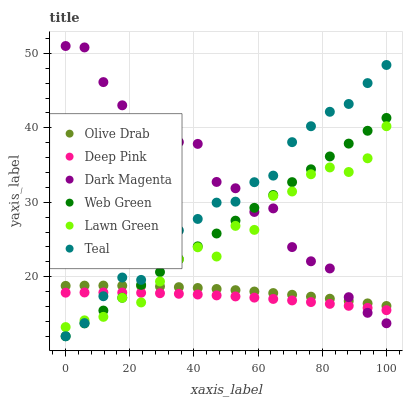Does Deep Pink have the minimum area under the curve?
Answer yes or no. Yes. Does Dark Magenta have the maximum area under the curve?
Answer yes or no. Yes. Does Dark Magenta have the minimum area under the curve?
Answer yes or no. No. Does Deep Pink have the maximum area under the curve?
Answer yes or no. No. Is Web Green the smoothest?
Answer yes or no. Yes. Is Dark Magenta the roughest?
Answer yes or no. Yes. Is Deep Pink the smoothest?
Answer yes or no. No. Is Deep Pink the roughest?
Answer yes or no. No. Does Web Green have the lowest value?
Answer yes or no. Yes. Does Deep Pink have the lowest value?
Answer yes or no. No. Does Dark Magenta have the highest value?
Answer yes or no. Yes. Does Deep Pink have the highest value?
Answer yes or no. No. Is Deep Pink less than Olive Drab?
Answer yes or no. Yes. Is Olive Drab greater than Deep Pink?
Answer yes or no. Yes. Does Web Green intersect Deep Pink?
Answer yes or no. Yes. Is Web Green less than Deep Pink?
Answer yes or no. No. Is Web Green greater than Deep Pink?
Answer yes or no. No. Does Deep Pink intersect Olive Drab?
Answer yes or no. No. 